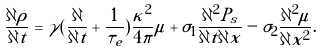<formula> <loc_0><loc_0><loc_500><loc_500>\frac { \partial \rho } { \partial t } = \gamma ( \frac { \partial } { \partial t } + \frac { 1 } { \tau _ { e } } ) \frac { \kappa ^ { 2 } } { 4 \pi } \mu + \sigma _ { 1 } \frac { \partial ^ { 2 } P _ { s } } { \partial t \partial x } - \sigma _ { 2 } \frac { \partial ^ { 2 } \mu } { \partial x ^ { 2 } } .</formula> 